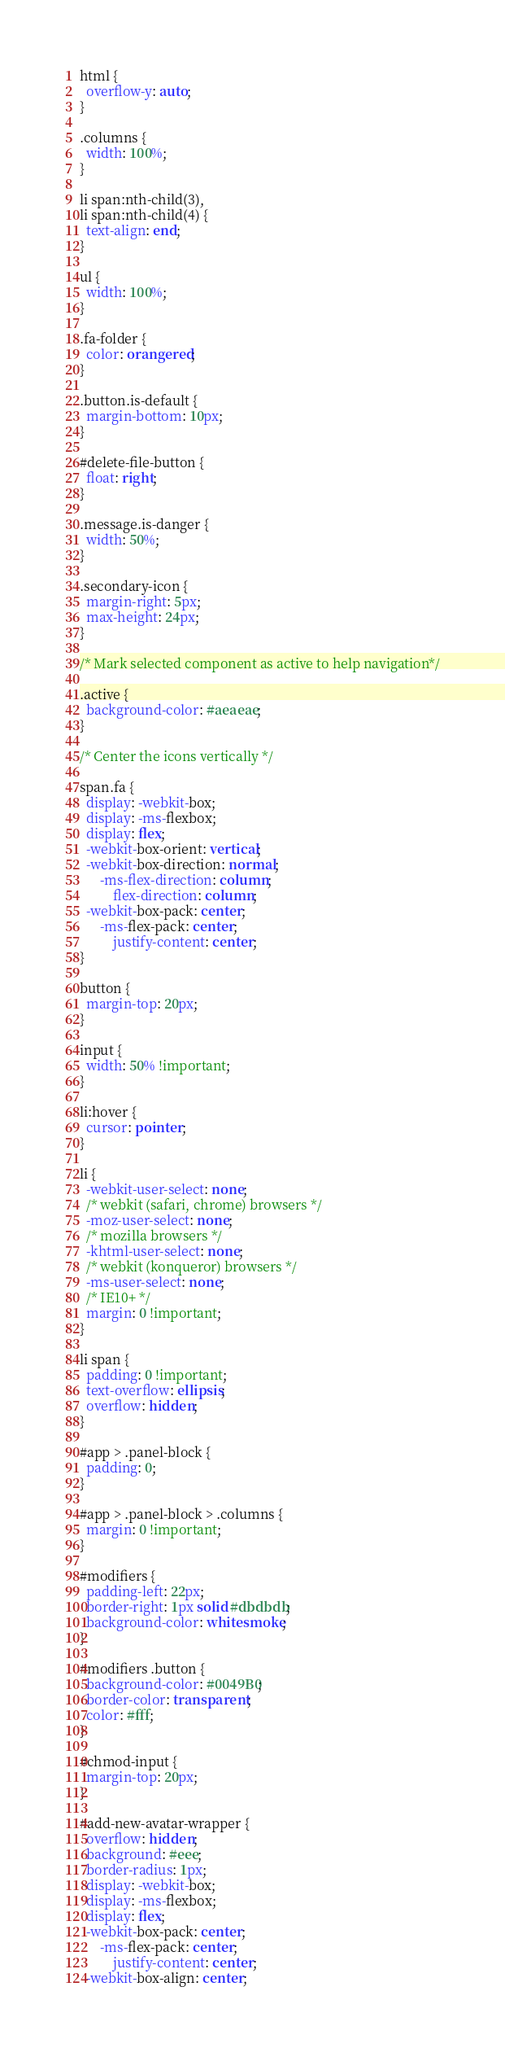Convert code to text. <code><loc_0><loc_0><loc_500><loc_500><_CSS_>html {
  overflow-y: auto;
}

.columns {
  width: 100%;
}

li span:nth-child(3),
li span:nth-child(4) {
  text-align: end;
}

ul {
  width: 100%;
}

.fa-folder {
  color: orangered;
}

.button.is-default {
  margin-bottom: 10px;
}

#delete-file-button {
  float: right;
}

.message.is-danger {
  width: 50%;
}

.secondary-icon {
  margin-right: 5px;
  max-height: 24px;
}

/* Mark selected component as active to help navigation*/

.active {
  background-color: #aeaeae;
}

/* Center the icons vertically */

span.fa {
  display: -webkit-box;
  display: -ms-flexbox;
  display: flex;
  -webkit-box-orient: vertical;
  -webkit-box-direction: normal;
      -ms-flex-direction: column;
          flex-direction: column;
  -webkit-box-pack: center;
      -ms-flex-pack: center;
          justify-content: center;
}

button {
  margin-top: 20px;
}

input {
  width: 50% !important;
}

li:hover {
  cursor: pointer;
}

li {
  -webkit-user-select: none;
  /* webkit (safari, chrome) browsers */
  -moz-user-select: none;
  /* mozilla browsers */
  -khtml-user-select: none;
  /* webkit (konqueror) browsers */
  -ms-user-select: none;
  /* IE10+ */
  margin: 0 !important;
}

li span {
  padding: 0 !important;
  text-overflow: ellipsis;
  overflow: hidden;
}

#app > .panel-block {
  padding: 0;
}

#app > .panel-block > .columns {
  margin: 0 !important;
}

#modifiers {
  padding-left: 22px;
  border-right: 1px solid #dbdbdb;
  background-color: whitesmoke;
}

#modifiers .button {
  background-color: #0049B0;
  border-color: transparent;
  color: #fff;
}

#chmod-input {
  margin-top: 20px;
}

#add-new-avatar-wrapper {
  overflow: hidden;
  background: #eee;
  border-radius: 1px;
  display: -webkit-box;
  display: -ms-flexbox;
  display: flex;
  -webkit-box-pack: center;
      -ms-flex-pack: center;
          justify-content: center;
  -webkit-box-align: center;</code> 